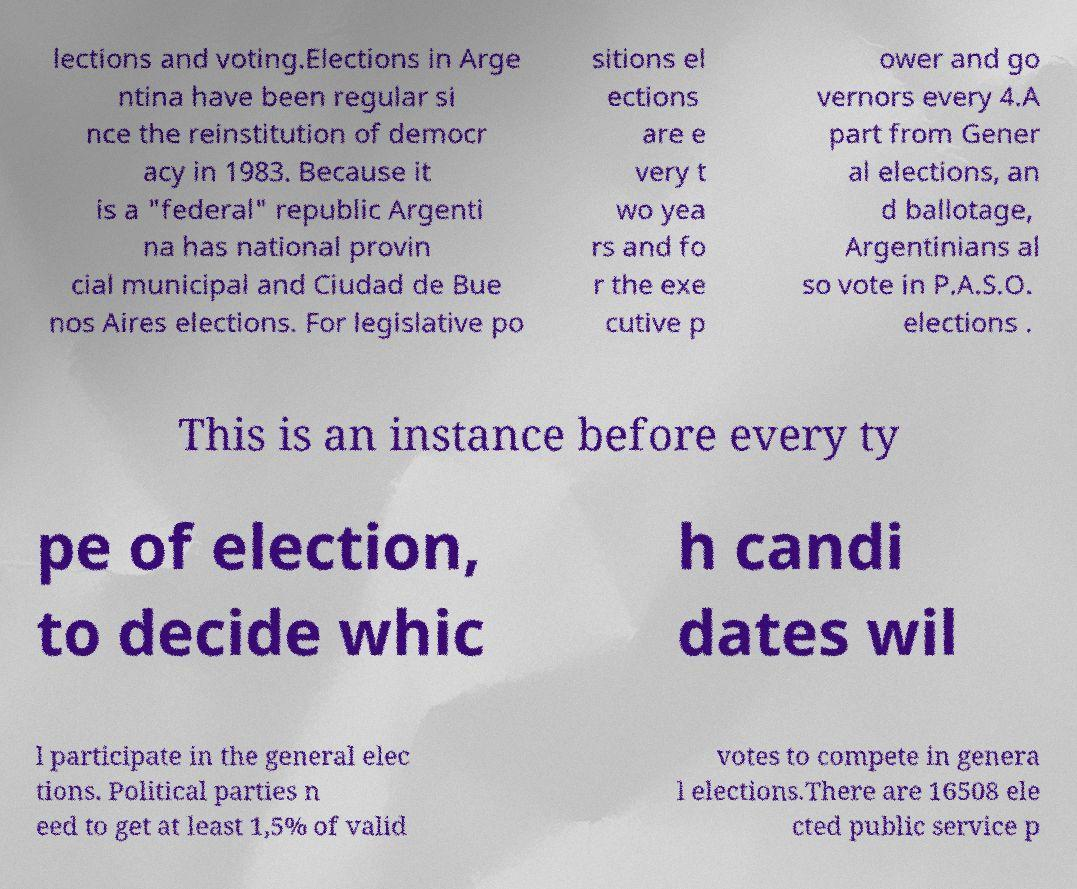Can you accurately transcribe the text from the provided image for me? lections and voting.Elections in Arge ntina have been regular si nce the reinstitution of democr acy in 1983. Because it is a "federal" republic Argenti na has national provin cial municipal and Ciudad de Bue nos Aires elections. For legislative po sitions el ections are e very t wo yea rs and fo r the exe cutive p ower and go vernors every 4.A part from Gener al elections, an d ballotage, Argentinians al so vote in P.A.S.O. elections . This is an instance before every ty pe of election, to decide whic h candi dates wil l participate in the general elec tions. Political parties n eed to get at least 1,5% of valid votes to compete in genera l elections.There are 16508 ele cted public service p 